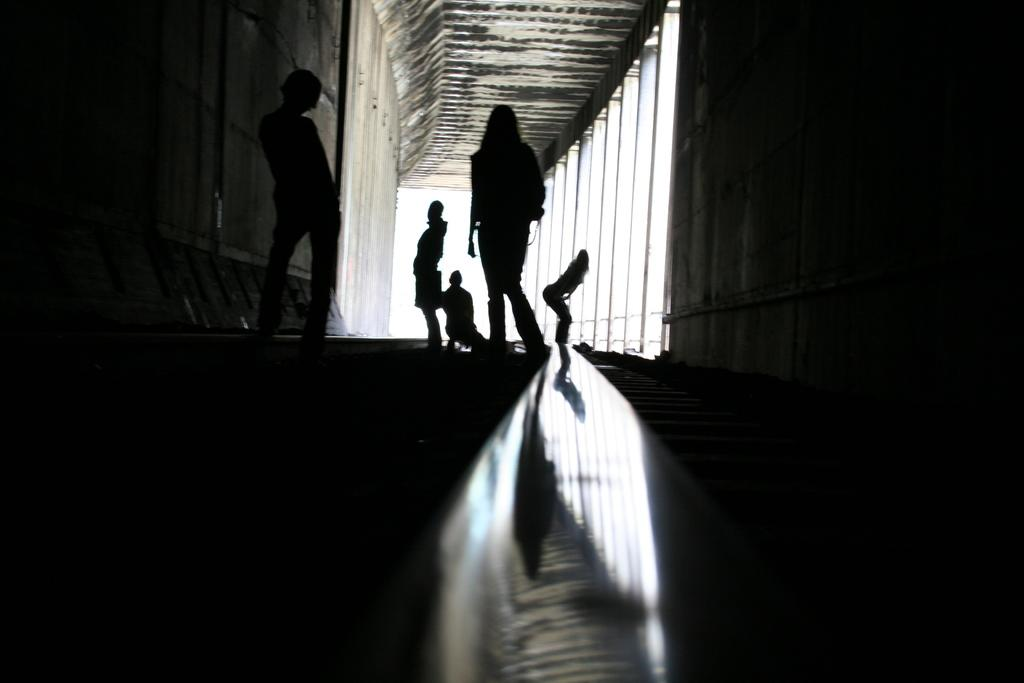How many people are in the image? There are five persons in the image. What are the persons doing in the image? The persons are on the floor. What architectural features can be seen in the image? There are pillars and a wall in the image. Where might the image have been taken? The image may have been taken in a building, given the presence of pillars and a wall. What is the thought process of the person in the image who is not present? There is no person in the image who is not present, so it is not possible to determine their thought process. 